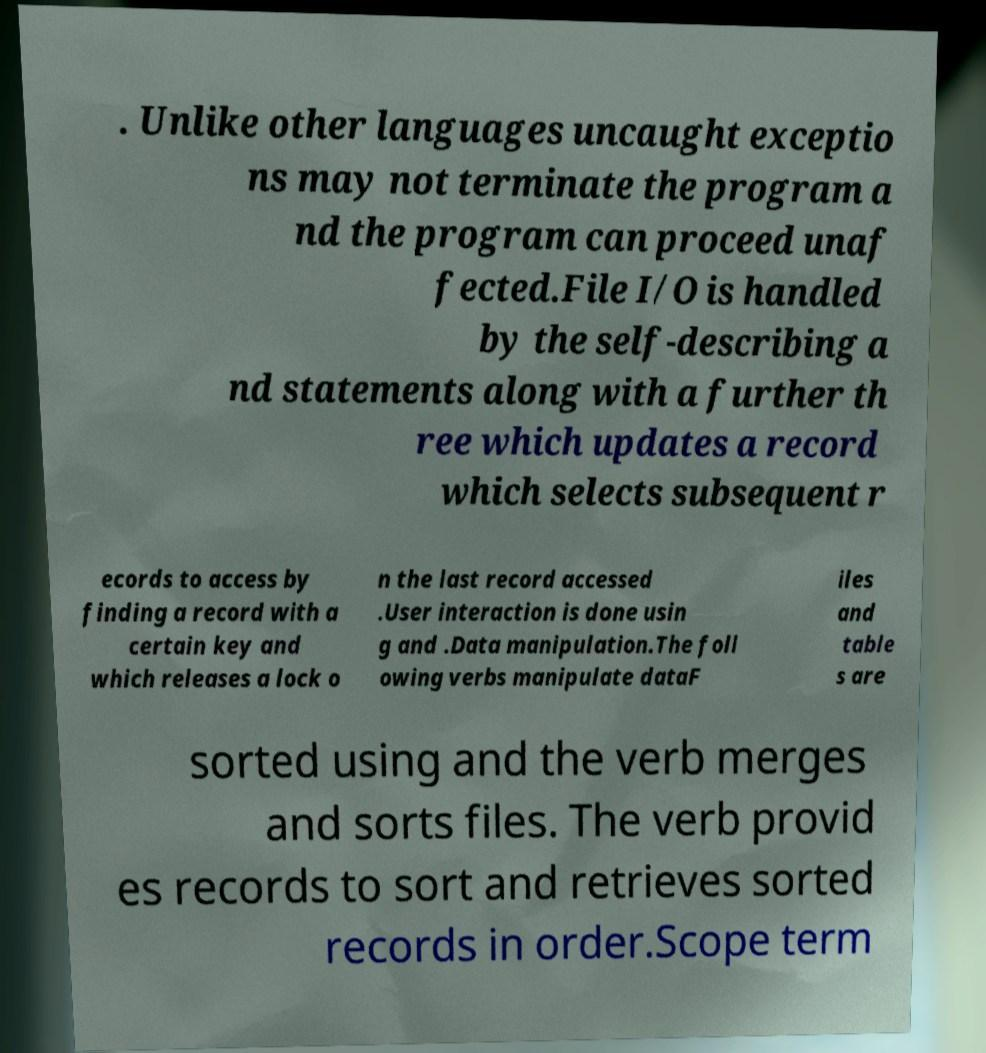Please identify and transcribe the text found in this image. . Unlike other languages uncaught exceptio ns may not terminate the program a nd the program can proceed unaf fected.File I/O is handled by the self-describing a nd statements along with a further th ree which updates a record which selects subsequent r ecords to access by finding a record with a certain key and which releases a lock o n the last record accessed .User interaction is done usin g and .Data manipulation.The foll owing verbs manipulate dataF iles and table s are sorted using and the verb merges and sorts files. The verb provid es records to sort and retrieves sorted records in order.Scope term 